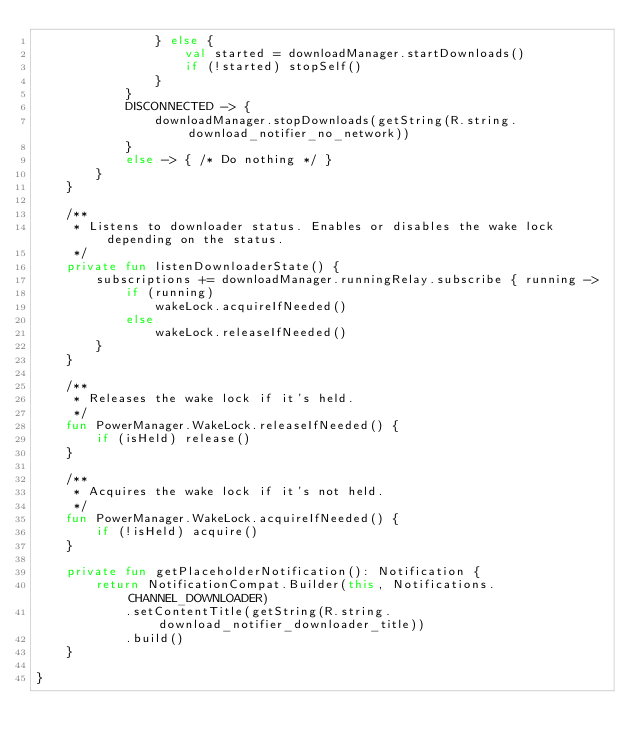Convert code to text. <code><loc_0><loc_0><loc_500><loc_500><_Kotlin_>                } else {
                    val started = downloadManager.startDownloads()
                    if (!started) stopSelf()
                }
            }
            DISCONNECTED -> {
                downloadManager.stopDownloads(getString(R.string.download_notifier_no_network))
            }
            else -> { /* Do nothing */ }
        }
    }

    /**
     * Listens to downloader status. Enables or disables the wake lock depending on the status.
     */
    private fun listenDownloaderState() {
        subscriptions += downloadManager.runningRelay.subscribe { running ->
            if (running)
                wakeLock.acquireIfNeeded()
            else
                wakeLock.releaseIfNeeded()
        }
    }

    /**
     * Releases the wake lock if it's held.
     */
    fun PowerManager.WakeLock.releaseIfNeeded() {
        if (isHeld) release()
    }

    /**
     * Acquires the wake lock if it's not held.
     */
    fun PowerManager.WakeLock.acquireIfNeeded() {
        if (!isHeld) acquire()
    }

    private fun getPlaceholderNotification(): Notification {
        return NotificationCompat.Builder(this, Notifications.CHANNEL_DOWNLOADER)
            .setContentTitle(getString(R.string.download_notifier_downloader_title))
            .build()
    }

}
</code> 